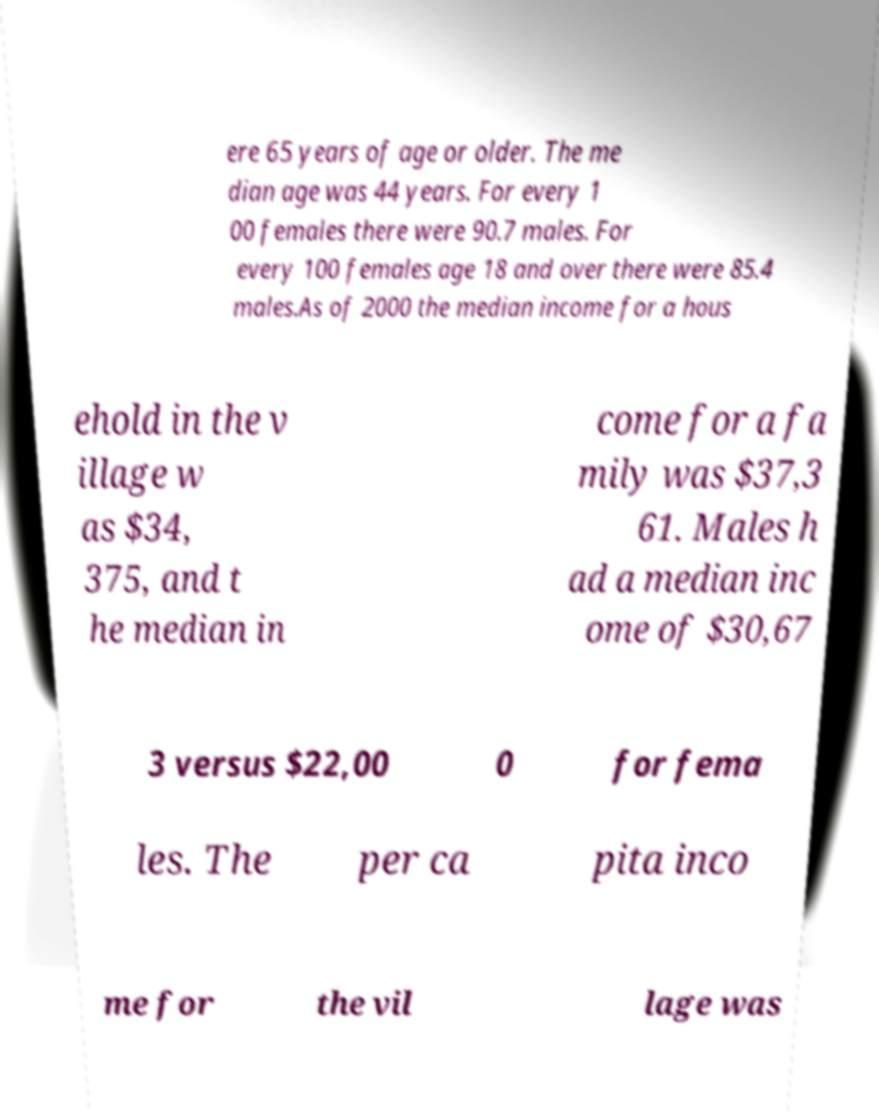What messages or text are displayed in this image? I need them in a readable, typed format. ere 65 years of age or older. The me dian age was 44 years. For every 1 00 females there were 90.7 males. For every 100 females age 18 and over there were 85.4 males.As of 2000 the median income for a hous ehold in the v illage w as $34, 375, and t he median in come for a fa mily was $37,3 61. Males h ad a median inc ome of $30,67 3 versus $22,00 0 for fema les. The per ca pita inco me for the vil lage was 